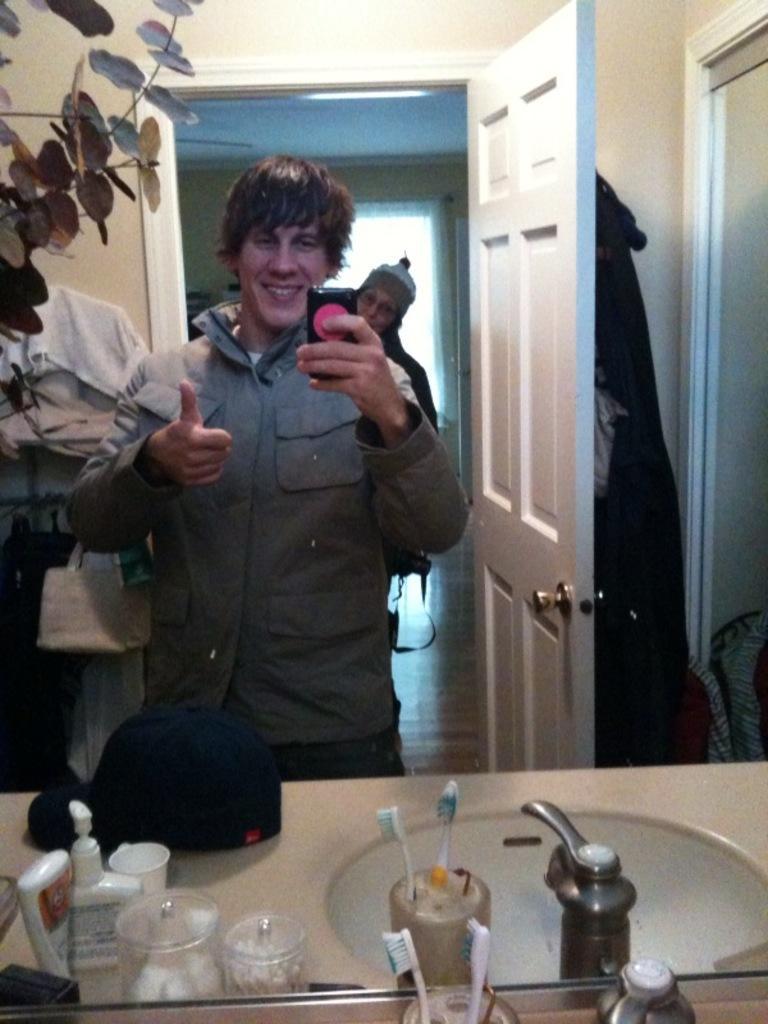How would you summarize this image in a sentence or two? In this picture there is a person standing and holding a mobile in his hand and there is another person behind him and there is a wash basin and some other objects in front of him and there is a door in the right corner and there are some other objects in the left corner. 